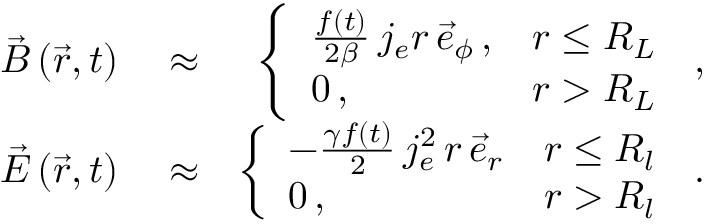<formula> <loc_0><loc_0><loc_500><loc_500>\begin{array} { r l r } { \vec { B } \left ( \vec { r } , t \right ) } & \approx } & { \left \{ \begin{array} { l l } { \frac { f ( t ) } { 2 \beta } \, j _ { e } r \, \vec { e } _ { \phi } \, , } & { r \leq R _ { L } } \\ { 0 \, , } & { r > R _ { L } } \end{array} \, , } \\ { \vec { E } \left ( \vec { r } , t \right ) } & \approx } & { \left \{ \begin{array} { l l } { - \frac { \gamma f ( t ) } { 2 } \, j _ { e } ^ { 2 } \, r \, \vec { e } _ { r } } & { r \leq R _ { l } } \\ { 0 \, , } & { r > R _ { l } } \end{array} \, . } \end{array}</formula> 